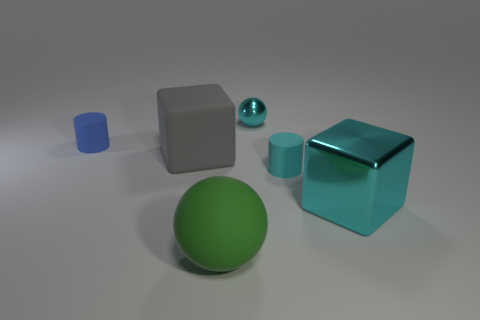The large metallic cube is what color?
Ensure brevity in your answer.  Cyan. The small cylinder that is left of the small thing that is behind the tiny matte cylinder behind the cyan cylinder is made of what material?
Keep it short and to the point. Rubber. The cyan thing that is made of the same material as the blue cylinder is what size?
Your answer should be compact. Small. Are there any other large matte spheres that have the same color as the big sphere?
Ensure brevity in your answer.  No. Is the size of the matte sphere the same as the metal thing behind the gray block?
Give a very brief answer. No. There is a tiny cylinder behind the tiny cylinder that is on the right side of the large green rubber sphere; what number of cylinders are to the right of it?
Keep it short and to the point. 1. There is a block that is the same color as the tiny metallic ball; what is its size?
Make the answer very short. Large. Are there any cyan matte objects to the left of the tiny blue rubber cylinder?
Your answer should be compact. No. What shape is the tiny cyan shiny thing?
Provide a short and direct response. Sphere. The cyan shiny object that is right of the matte cylinder to the right of the ball in front of the gray matte thing is what shape?
Your answer should be compact. Cube. 